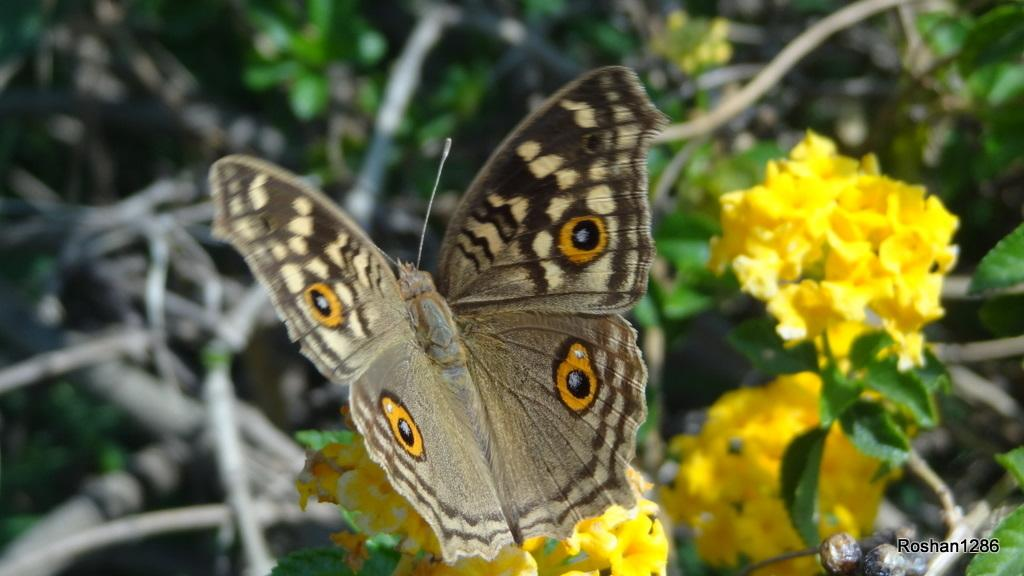What is the main subject of the image? There is a butterfly in the image. What is the butterfly resting on? The butterfly is on yellow flowers. Are there any other flowers in the image besides the yellow ones? Yes, there are other flowers beside the yellow flowers. Is there any text present in the image? Yes, there is text written in the right bottom corner of the image. What is the weight of the leaf next to the butterfly in the image? There is no leaf present in the image, so it is not possible to determine its weight. 